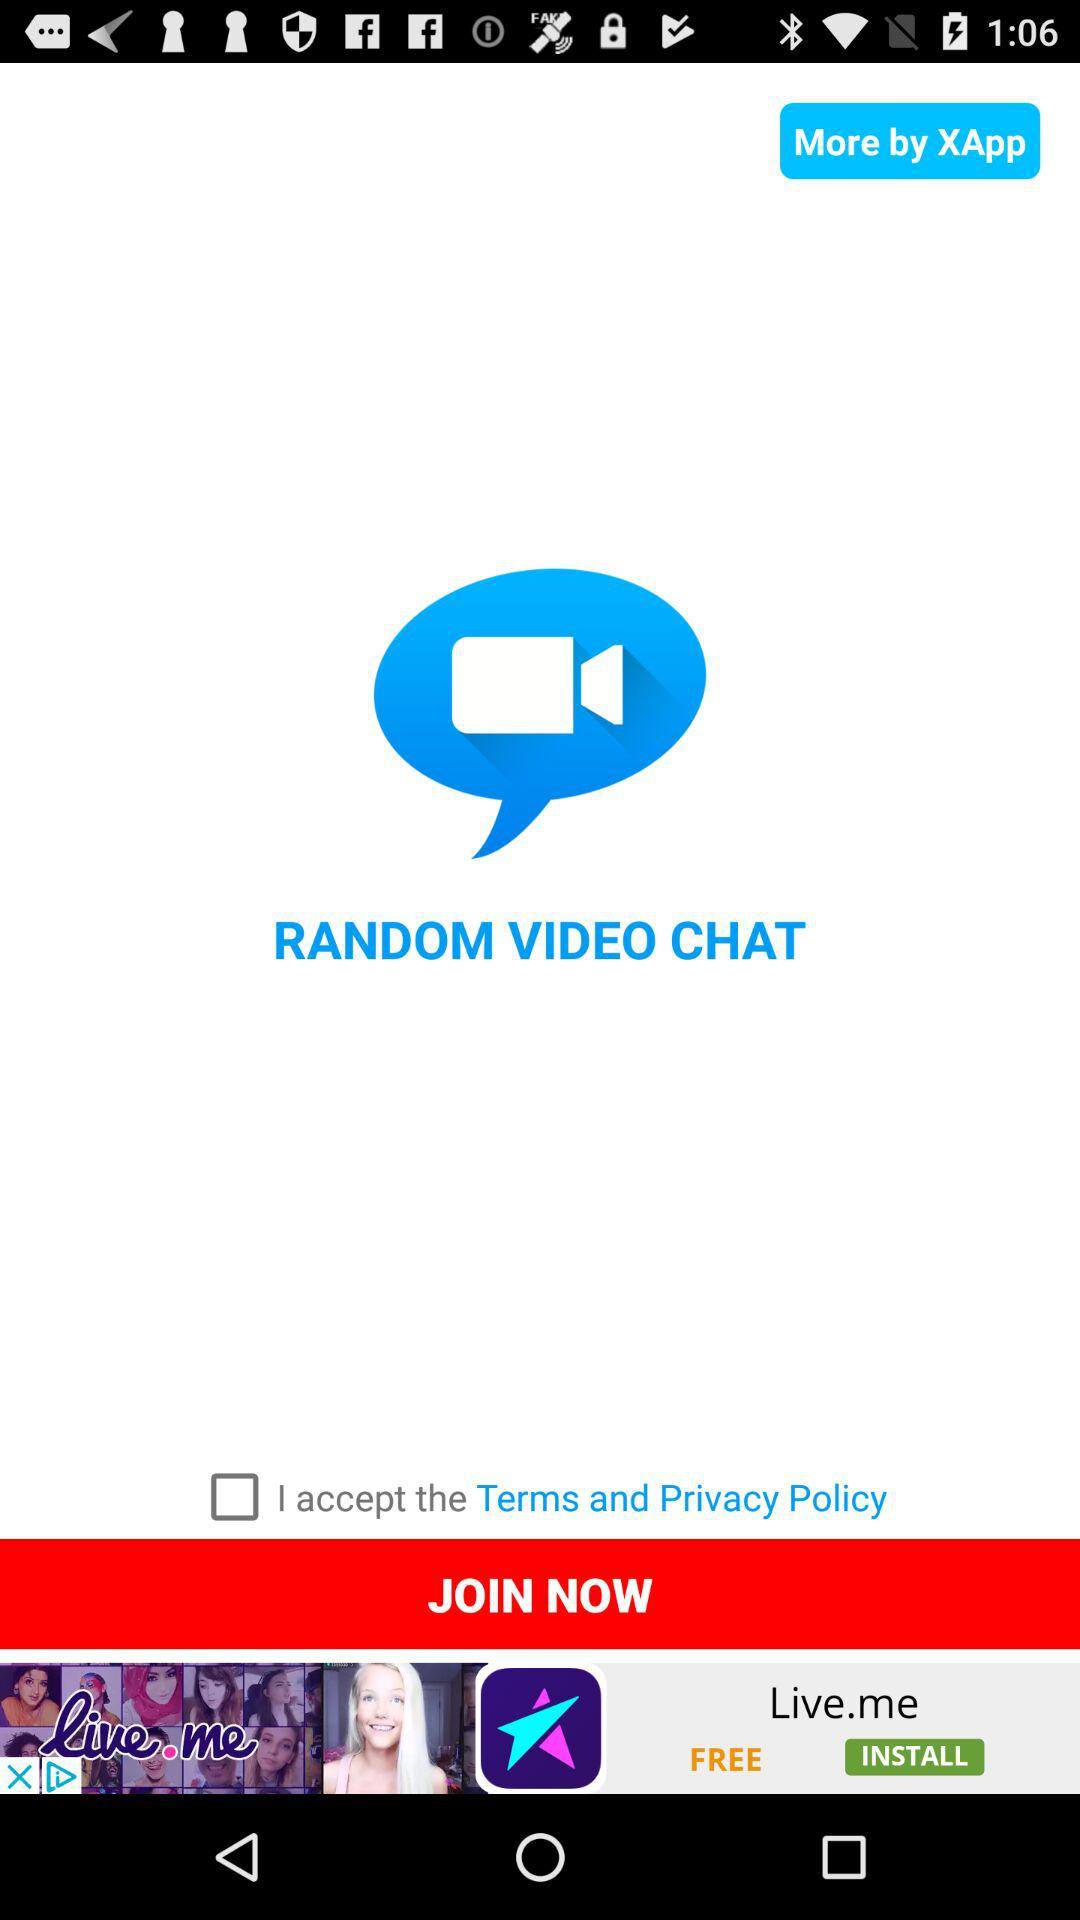What is the name of the application? The name of the application is "X Random Video Chat". 